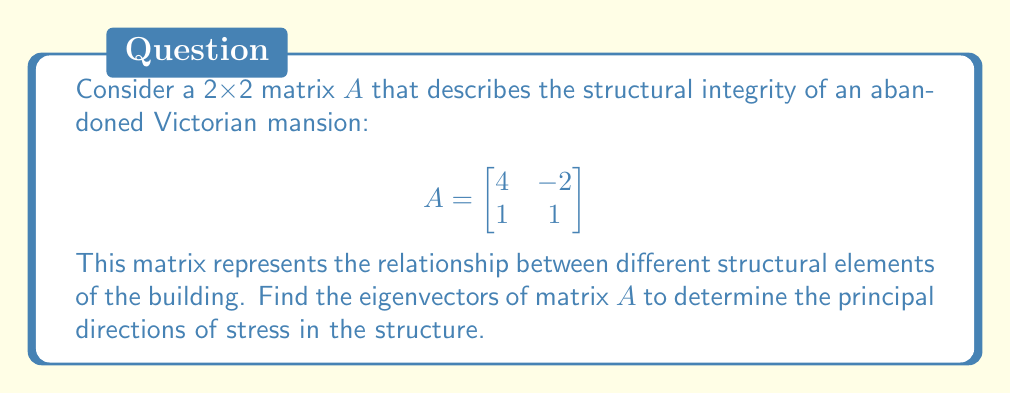What is the answer to this math problem? To find the eigenvectors of matrix $A$, we follow these steps:

1) First, we need to find the eigenvalues by solving the characteristic equation:
   
   $det(A - \lambda I) = 0$

   $$\begin{vmatrix}
   4-\lambda & -2 \\
   1 & 1-\lambda
   \end{vmatrix} = 0$$

   $(4-\lambda)(1-\lambda) - (-2)(1) = 0$
   
   $4 - 5\lambda + \lambda^2 + 2 = 0$
   
   $\lambda^2 - 5\lambda + 6 = 0$

2) Solve this quadratic equation:
   
   $(\lambda - 3)(\lambda - 2) = 0$
   
   So, $\lambda_1 = 3$ and $\lambda_2 = 2$

3) For $\lambda_1 = 3$, we solve $(A - 3I)v = 0$:

   $$\begin{bmatrix}
   1 & -2 \\
   1 & -2
   \end{bmatrix} \begin{bmatrix}
   v_1 \\ v_2
   \end{bmatrix} = \begin{bmatrix}
   0 \\ 0
   \end{bmatrix}$$

   This gives us $v_1 = 2v_2$. Let $v_2 = 1$, then $v_1 = 2$.
   
   Eigenvector for $\lambda_1 = 3$ is $v_1 = \begin{bmatrix} 2 \\ 1 \end{bmatrix}$

4) For $\lambda_2 = 2$, we solve $(A - 2I)v = 0$:

   $$\begin{bmatrix}
   2 & -2 \\
   1 & -1
   \end{bmatrix} \begin{bmatrix}
   v_1 \\ v_2
   \end{bmatrix} = \begin{bmatrix}
   0 \\ 0
   \end{bmatrix}$$

   This gives us $v_1 = v_2$. Let $v_1 = 1$, then $v_2 = 1$.
   
   Eigenvector for $\lambda_2 = 2$ is $v_2 = \begin{bmatrix} 1 \\ 1 \end{bmatrix}$
Answer: $v_1 = \begin{bmatrix} 2 \\ 1 \end{bmatrix}$, $v_2 = \begin{bmatrix} 1 \\ 1 \end{bmatrix}$ 